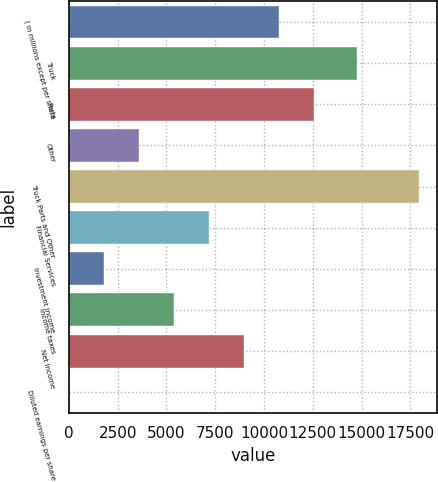Convert chart to OTSL. <chart><loc_0><loc_0><loc_500><loc_500><bar_chart><fcel>( in millions except per share<fcel>Truck<fcel>Parts<fcel>Other<fcel>Truck Parts and Other<fcel>Financial Services<fcel>Investment income<fcel>Income taxes<fcel>Net Income<fcel>Diluted earnings per share<nl><fcel>10767.5<fcel>14782.5<fcel>12561.3<fcel>3592.17<fcel>17942.8<fcel>7179.83<fcel>1798.34<fcel>5386<fcel>8973.66<fcel>4.51<nl></chart> 